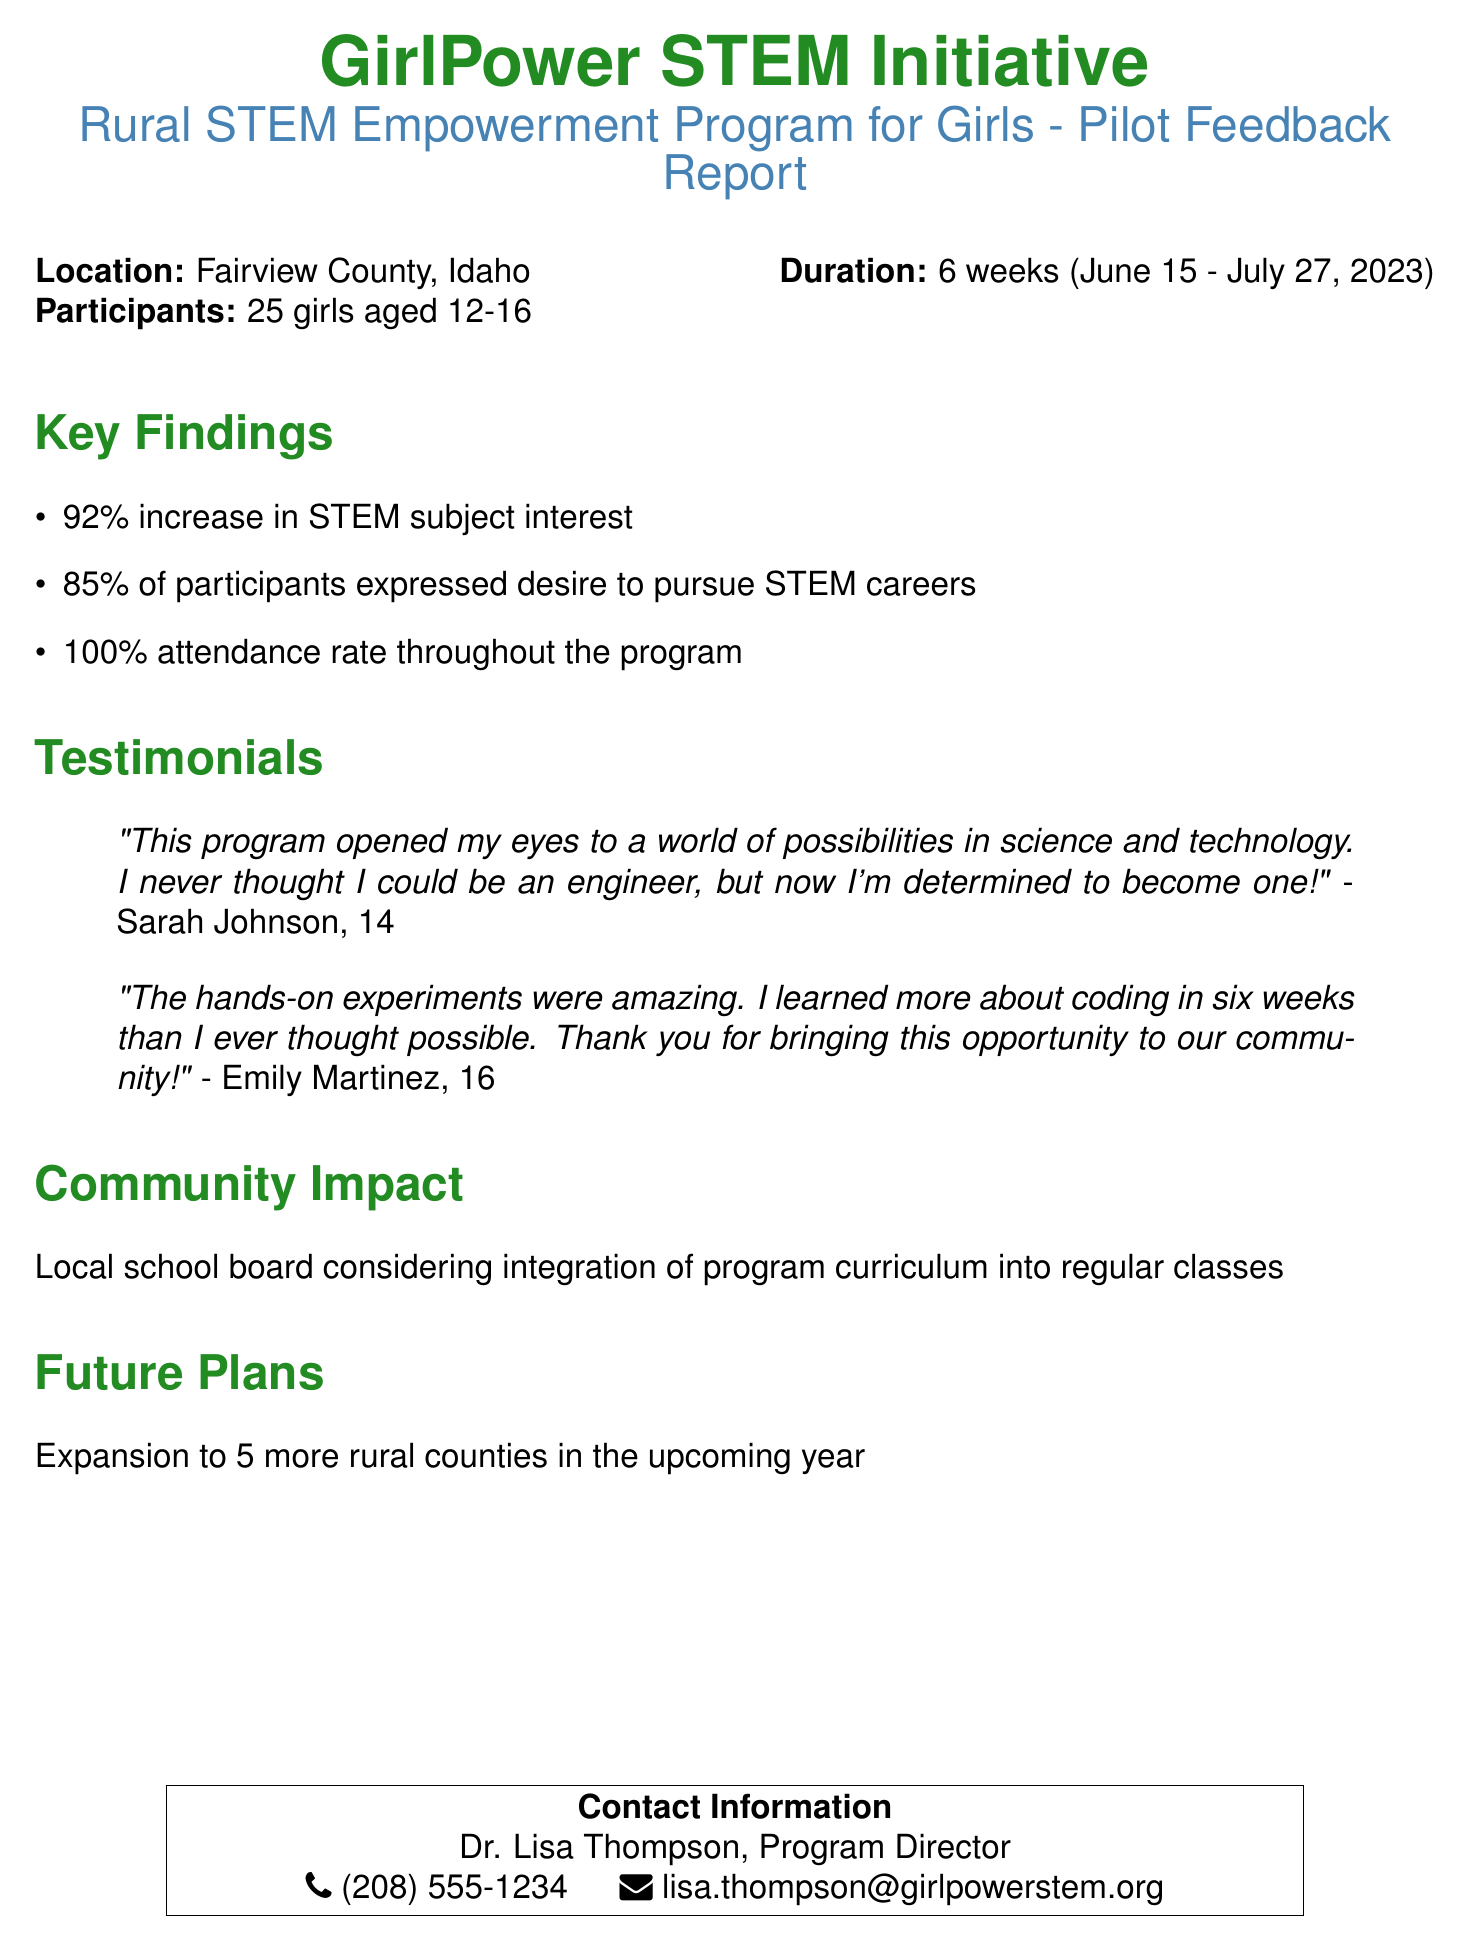What is the location of the program? The document states that the program took place in Fairview County, Idaho.
Answer: Fairview County, Idaho What is the age range of participants? The document mentions that participants were aged 12-16.
Answer: 12-16 What percentage of participants expressed a desire to pursue STEM careers? According to the document, 85% of participants expressed this desire.
Answer: 85% How long did the program last? The duration of the program, as indicated in the document, was six weeks.
Answer: 6 weeks What was the attendance rate throughout the program? The document reports a 100% attendance rate during the program.
Answer: 100% Who is the Program Director? The document identifies Dr. Lisa Thompson as the Program Director.
Answer: Dr. Lisa Thompson What major action is the local school board considering? The document states that the local school board is considering program curriculum integration into regular classes.
Answer: Integration of program curriculum What are the future plans for the program? The document mentions plans to expand to five more rural counties in the upcoming year.
Answer: 5 more rural counties What was one of the key findings regarding interest in STEM subjects? The document indicates a 92% increase in STEM subject interest as a key finding.
Answer: 92% increase What did Sarah Johnson want to become after the program? The document features Sarah Johnson stating her determination to become an engineer.
Answer: Engineer 